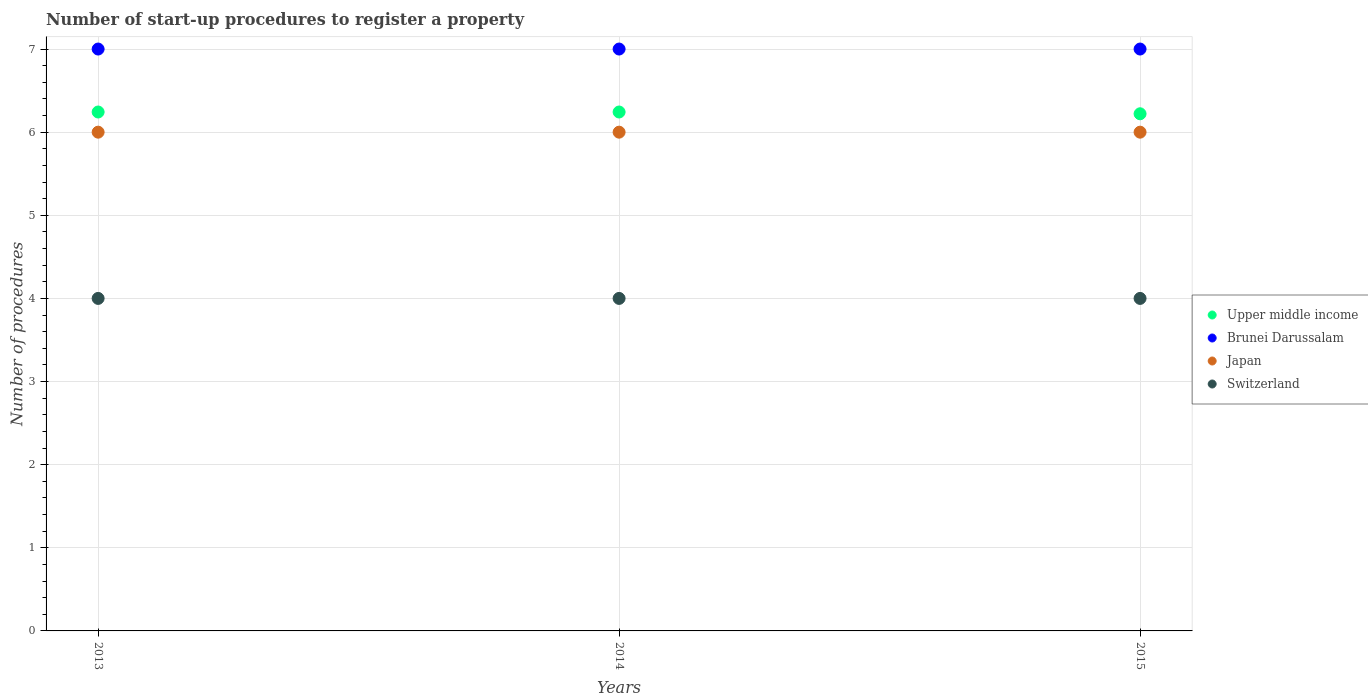Across all years, what is the maximum number of procedures required to register a property in Brunei Darussalam?
Make the answer very short. 7. Across all years, what is the minimum number of procedures required to register a property in Switzerland?
Make the answer very short. 4. In which year was the number of procedures required to register a property in Upper middle income maximum?
Keep it short and to the point. 2013. In which year was the number of procedures required to register a property in Brunei Darussalam minimum?
Provide a short and direct response. 2013. What is the total number of procedures required to register a property in Switzerland in the graph?
Ensure brevity in your answer.  12. What is the difference between the number of procedures required to register a property in Japan in 2014 and that in 2015?
Provide a succinct answer. 0. What is the difference between the number of procedures required to register a property in Brunei Darussalam in 2013 and the number of procedures required to register a property in Upper middle income in 2014?
Make the answer very short. 0.76. In how many years, is the number of procedures required to register a property in Brunei Darussalam greater than 4.8?
Your answer should be very brief. 3. What is the ratio of the number of procedures required to register a property in Switzerland in 2014 to that in 2015?
Offer a terse response. 1. Is the difference between the number of procedures required to register a property in Japan in 2014 and 2015 greater than the difference between the number of procedures required to register a property in Brunei Darussalam in 2014 and 2015?
Give a very brief answer. No. What is the difference between the highest and the second highest number of procedures required to register a property in Japan?
Your response must be concise. 0. What is the difference between the highest and the lowest number of procedures required to register a property in Switzerland?
Keep it short and to the point. 0. In how many years, is the number of procedures required to register a property in Brunei Darussalam greater than the average number of procedures required to register a property in Brunei Darussalam taken over all years?
Offer a very short reply. 0. Is the sum of the number of procedures required to register a property in Japan in 2014 and 2015 greater than the maximum number of procedures required to register a property in Brunei Darussalam across all years?
Offer a terse response. Yes. Does the number of procedures required to register a property in Brunei Darussalam monotonically increase over the years?
Provide a succinct answer. No. Is the number of procedures required to register a property in Brunei Darussalam strictly less than the number of procedures required to register a property in Japan over the years?
Your answer should be very brief. No. How many dotlines are there?
Make the answer very short. 4. How many years are there in the graph?
Ensure brevity in your answer.  3. Are the values on the major ticks of Y-axis written in scientific E-notation?
Your response must be concise. No. Does the graph contain grids?
Your answer should be compact. Yes. What is the title of the graph?
Give a very brief answer. Number of start-up procedures to register a property. Does "Ecuador" appear as one of the legend labels in the graph?
Make the answer very short. No. What is the label or title of the Y-axis?
Offer a very short reply. Number of procedures. What is the Number of procedures of Upper middle income in 2013?
Your answer should be compact. 6.24. What is the Number of procedures of Brunei Darussalam in 2013?
Ensure brevity in your answer.  7. What is the Number of procedures of Upper middle income in 2014?
Provide a short and direct response. 6.24. What is the Number of procedures of Japan in 2014?
Keep it short and to the point. 6. What is the Number of procedures in Switzerland in 2014?
Your response must be concise. 4. What is the Number of procedures in Upper middle income in 2015?
Your answer should be very brief. 6.22. Across all years, what is the maximum Number of procedures in Upper middle income?
Your answer should be very brief. 6.24. Across all years, what is the maximum Number of procedures in Brunei Darussalam?
Your response must be concise. 7. Across all years, what is the maximum Number of procedures in Switzerland?
Give a very brief answer. 4. Across all years, what is the minimum Number of procedures in Upper middle income?
Give a very brief answer. 6.22. Across all years, what is the minimum Number of procedures of Japan?
Offer a terse response. 6. What is the total Number of procedures in Upper middle income in the graph?
Your response must be concise. 18.71. What is the total Number of procedures in Switzerland in the graph?
Offer a very short reply. 12. What is the difference between the Number of procedures of Switzerland in 2013 and that in 2014?
Provide a short and direct response. 0. What is the difference between the Number of procedures in Upper middle income in 2013 and that in 2015?
Ensure brevity in your answer.  0.02. What is the difference between the Number of procedures in Japan in 2013 and that in 2015?
Ensure brevity in your answer.  0. What is the difference between the Number of procedures of Switzerland in 2013 and that in 2015?
Your response must be concise. 0. What is the difference between the Number of procedures in Upper middle income in 2014 and that in 2015?
Make the answer very short. 0.02. What is the difference between the Number of procedures of Switzerland in 2014 and that in 2015?
Your answer should be compact. 0. What is the difference between the Number of procedures of Upper middle income in 2013 and the Number of procedures of Brunei Darussalam in 2014?
Your answer should be compact. -0.76. What is the difference between the Number of procedures in Upper middle income in 2013 and the Number of procedures in Japan in 2014?
Ensure brevity in your answer.  0.24. What is the difference between the Number of procedures in Upper middle income in 2013 and the Number of procedures in Switzerland in 2014?
Make the answer very short. 2.24. What is the difference between the Number of procedures of Brunei Darussalam in 2013 and the Number of procedures of Switzerland in 2014?
Provide a short and direct response. 3. What is the difference between the Number of procedures of Upper middle income in 2013 and the Number of procedures of Brunei Darussalam in 2015?
Keep it short and to the point. -0.76. What is the difference between the Number of procedures of Upper middle income in 2013 and the Number of procedures of Japan in 2015?
Ensure brevity in your answer.  0.24. What is the difference between the Number of procedures of Upper middle income in 2013 and the Number of procedures of Switzerland in 2015?
Offer a terse response. 2.24. What is the difference between the Number of procedures of Brunei Darussalam in 2013 and the Number of procedures of Japan in 2015?
Offer a very short reply. 1. What is the difference between the Number of procedures of Brunei Darussalam in 2013 and the Number of procedures of Switzerland in 2015?
Give a very brief answer. 3. What is the difference between the Number of procedures of Japan in 2013 and the Number of procedures of Switzerland in 2015?
Make the answer very short. 2. What is the difference between the Number of procedures in Upper middle income in 2014 and the Number of procedures in Brunei Darussalam in 2015?
Provide a short and direct response. -0.76. What is the difference between the Number of procedures in Upper middle income in 2014 and the Number of procedures in Japan in 2015?
Ensure brevity in your answer.  0.24. What is the difference between the Number of procedures of Upper middle income in 2014 and the Number of procedures of Switzerland in 2015?
Your response must be concise. 2.24. What is the difference between the Number of procedures in Brunei Darussalam in 2014 and the Number of procedures in Japan in 2015?
Give a very brief answer. 1. What is the average Number of procedures of Upper middle income per year?
Offer a terse response. 6.24. What is the average Number of procedures of Japan per year?
Your answer should be compact. 6. In the year 2013, what is the difference between the Number of procedures in Upper middle income and Number of procedures in Brunei Darussalam?
Provide a succinct answer. -0.76. In the year 2013, what is the difference between the Number of procedures in Upper middle income and Number of procedures in Japan?
Offer a terse response. 0.24. In the year 2013, what is the difference between the Number of procedures of Upper middle income and Number of procedures of Switzerland?
Keep it short and to the point. 2.24. In the year 2013, what is the difference between the Number of procedures in Brunei Darussalam and Number of procedures in Japan?
Offer a very short reply. 1. In the year 2013, what is the difference between the Number of procedures in Brunei Darussalam and Number of procedures in Switzerland?
Make the answer very short. 3. In the year 2013, what is the difference between the Number of procedures in Japan and Number of procedures in Switzerland?
Provide a short and direct response. 2. In the year 2014, what is the difference between the Number of procedures in Upper middle income and Number of procedures in Brunei Darussalam?
Your answer should be compact. -0.76. In the year 2014, what is the difference between the Number of procedures of Upper middle income and Number of procedures of Japan?
Provide a succinct answer. 0.24. In the year 2014, what is the difference between the Number of procedures of Upper middle income and Number of procedures of Switzerland?
Offer a very short reply. 2.24. In the year 2014, what is the difference between the Number of procedures in Brunei Darussalam and Number of procedures in Switzerland?
Provide a succinct answer. 3. In the year 2014, what is the difference between the Number of procedures in Japan and Number of procedures in Switzerland?
Give a very brief answer. 2. In the year 2015, what is the difference between the Number of procedures in Upper middle income and Number of procedures in Brunei Darussalam?
Your answer should be very brief. -0.78. In the year 2015, what is the difference between the Number of procedures of Upper middle income and Number of procedures of Japan?
Your answer should be compact. 0.22. In the year 2015, what is the difference between the Number of procedures of Upper middle income and Number of procedures of Switzerland?
Provide a succinct answer. 2.22. In the year 2015, what is the difference between the Number of procedures in Brunei Darussalam and Number of procedures in Switzerland?
Offer a terse response. 3. What is the ratio of the Number of procedures of Upper middle income in 2013 to that in 2014?
Your answer should be very brief. 1. What is the ratio of the Number of procedures of Japan in 2013 to that in 2014?
Your response must be concise. 1. What is the ratio of the Number of procedures of Switzerland in 2013 to that in 2014?
Offer a very short reply. 1. What is the ratio of the Number of procedures of Japan in 2013 to that in 2015?
Offer a terse response. 1. What is the ratio of the Number of procedures of Switzerland in 2013 to that in 2015?
Your response must be concise. 1. What is the ratio of the Number of procedures in Switzerland in 2014 to that in 2015?
Provide a succinct answer. 1. What is the difference between the highest and the lowest Number of procedures of Upper middle income?
Your response must be concise. 0.02. What is the difference between the highest and the lowest Number of procedures of Brunei Darussalam?
Give a very brief answer. 0. What is the difference between the highest and the lowest Number of procedures of Japan?
Your answer should be compact. 0. What is the difference between the highest and the lowest Number of procedures in Switzerland?
Your response must be concise. 0. 